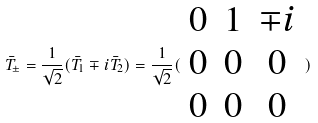Convert formula to latex. <formula><loc_0><loc_0><loc_500><loc_500>\bar { T } _ { \pm } = \frac { 1 } { \sqrt { 2 } } ( \bar { T } _ { 1 } \mp i \bar { T } _ { 2 } ) = \frac { 1 } { \sqrt { 2 } } ( \begin{array} { c c c } 0 & 1 & \mp i \\ 0 & 0 & 0 \\ 0 & 0 & 0 \end{array} )</formula> 